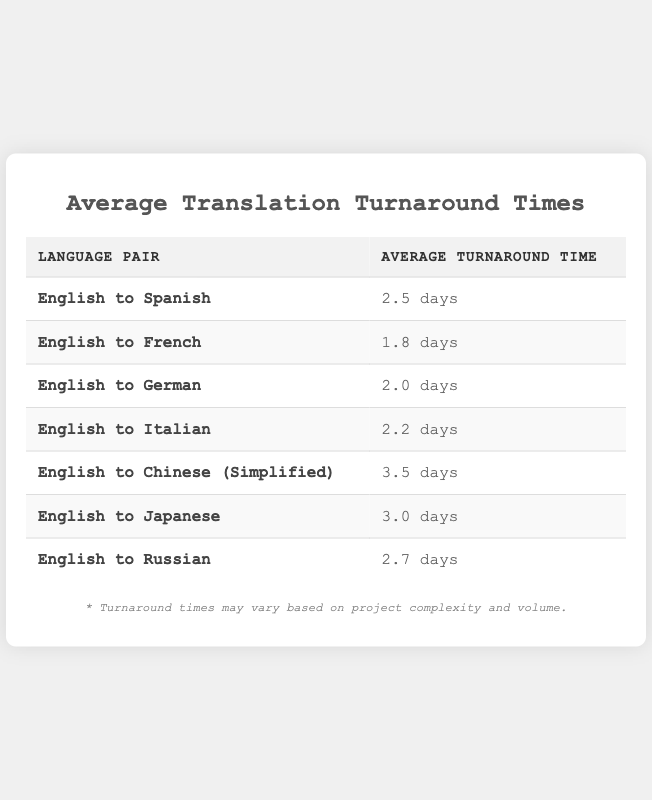What is the average turnaround time for English to French translations? The table clearly shows that the average turnaround time for English to French translations is listed as 1.8 days.
Answer: 1.8 days Which language pair has the longest average turnaround time? By examining the average turnaround times listed in the table, English to Chinese (Simplified) has the longest average turnaround time of 3.5 days.
Answer: English to Chinese (Simplified) What is the difference in average turnaround time between English to Spanish and English to Italian? The average turnaround time for English to Spanish is 2.5 days, and for English to Italian it is 2.2 days. The difference is calculated as 2.5 days - 2.2 days = 0.3 days.
Answer: 0.3 days Is the average turnaround time for English to Japanese greater than that for English to Russian? The average turnaround time for English to Japanese is 3.0 days, and for English to Russian it is 2.7 days. Since 3.0 days is greater than 2.7 days, the statement is true.
Answer: Yes What is the average of the turnaround times for English to Spanish, French, and German? The average is calculated by summing the turnaround times for the three pairs: 2.5 (Spanish) + 1.8 (French) + 2.0 (German) = 6.3 days. Dividing by 3 gives an average of 6.3 days / 3 = 2.1 days.
Answer: 2.1 days 